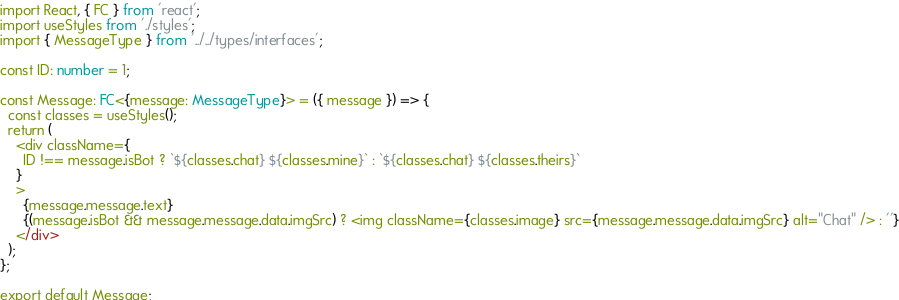Convert code to text. <code><loc_0><loc_0><loc_500><loc_500><_TypeScript_>import React, { FC } from 'react';
import useStyles from './styles';
import { MessageType } from '../../types/interfaces';

const ID: number = 1;

const Message: FC<{message: MessageType}> = ({ message }) => {
  const classes = useStyles();
  return (
    <div className={
      ID !== message.isBot ? `${classes.chat} ${classes.mine}` : `${classes.chat} ${classes.theirs}`
    }
    >
      {message.message.text}
      {(message.isBot && message.message.data.imgSrc) ? <img className={classes.image} src={message.message.data.imgSrc} alt="Chat" /> : ''}
    </div>
  );
};

export default Message;
</code> 